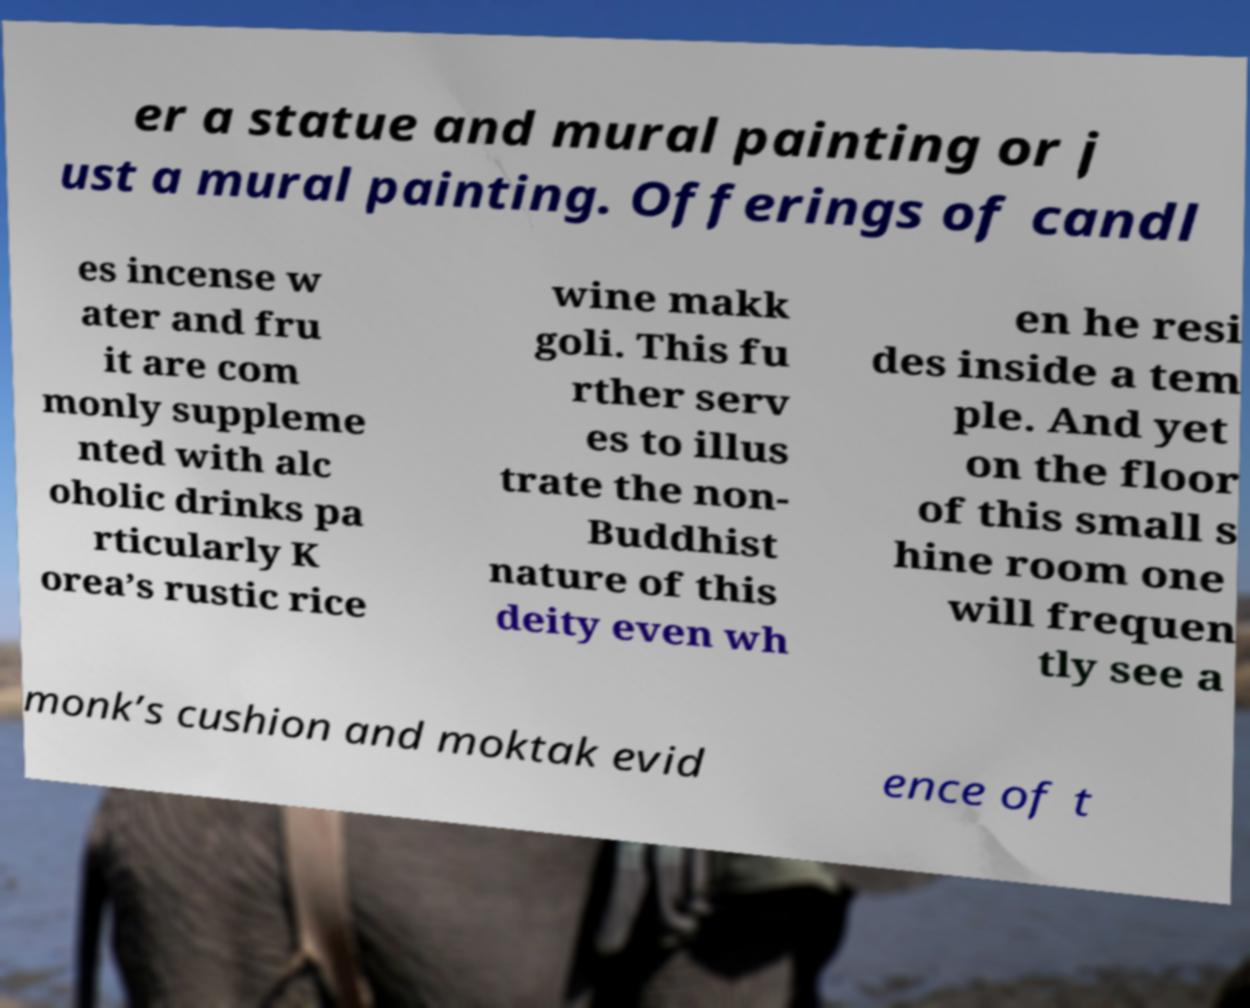What messages or text are displayed in this image? I need them in a readable, typed format. er a statue and mural painting or j ust a mural painting. Offerings of candl es incense w ater and fru it are com monly suppleme nted with alc oholic drinks pa rticularly K orea’s rustic rice wine makk goli. This fu rther serv es to illus trate the non- Buddhist nature of this deity even wh en he resi des inside a tem ple. And yet on the floor of this small s hine room one will frequen tly see a monk’s cushion and moktak evid ence of t 